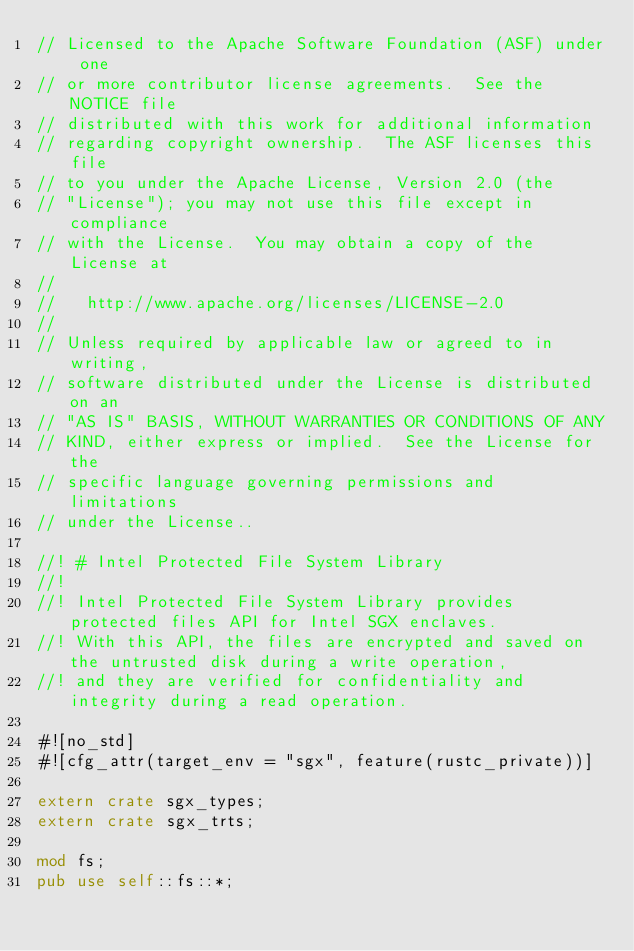Convert code to text. <code><loc_0><loc_0><loc_500><loc_500><_Rust_>// Licensed to the Apache Software Foundation (ASF) under one
// or more contributor license agreements.  See the NOTICE file
// distributed with this work for additional information
// regarding copyright ownership.  The ASF licenses this file
// to you under the Apache License, Version 2.0 (the
// "License"); you may not use this file except in compliance
// with the License.  You may obtain a copy of the License at
//
//   http://www.apache.org/licenses/LICENSE-2.0
//
// Unless required by applicable law or agreed to in writing,
// software distributed under the License is distributed on an
// "AS IS" BASIS, WITHOUT WARRANTIES OR CONDITIONS OF ANY
// KIND, either express or implied.  See the License for the
// specific language governing permissions and limitations
// under the License..

//! # Intel Protected File System Library
//!
//! Intel Protected File System Library provides protected files API for Intel SGX enclaves.
//! With this API, the files are encrypted and saved on the untrusted disk during a write operation,
//! and they are verified for confidentiality and integrity during a read operation.

#![no_std]
#![cfg_attr(target_env = "sgx", feature(rustc_private))]

extern crate sgx_types;
extern crate sgx_trts;

mod fs;
pub use self::fs::*;
</code> 